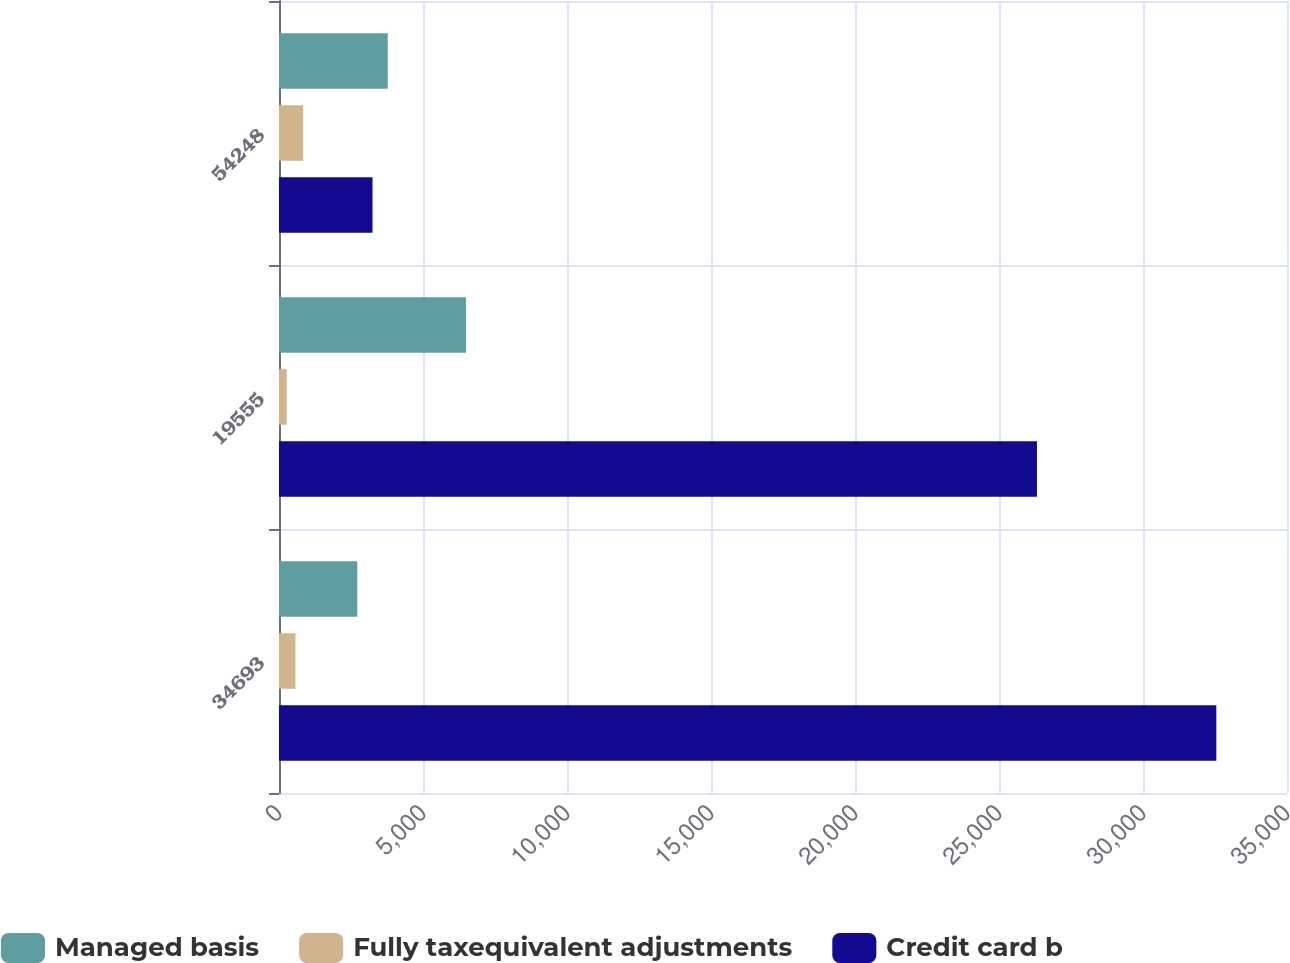Convert chart. <chart><loc_0><loc_0><loc_500><loc_500><stacked_bar_chart><ecel><fcel>34693<fcel>19555<fcel>54248<nl><fcel>Managed basis<fcel>2718<fcel>6494<fcel>3776<nl><fcel>Fully taxequivalent adjustments<fcel>571<fcel>269<fcel>840<nl><fcel>Credit card b<fcel>32546<fcel>26318<fcel>3247<nl></chart> 